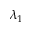<formula> <loc_0><loc_0><loc_500><loc_500>\lambda _ { 1 }</formula> 